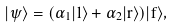Convert formula to latex. <formula><loc_0><loc_0><loc_500><loc_500>| \psi \rangle = ( \alpha _ { 1 } | l \rangle + \alpha _ { 2 } | r \rangle ) | f \rangle ,</formula> 